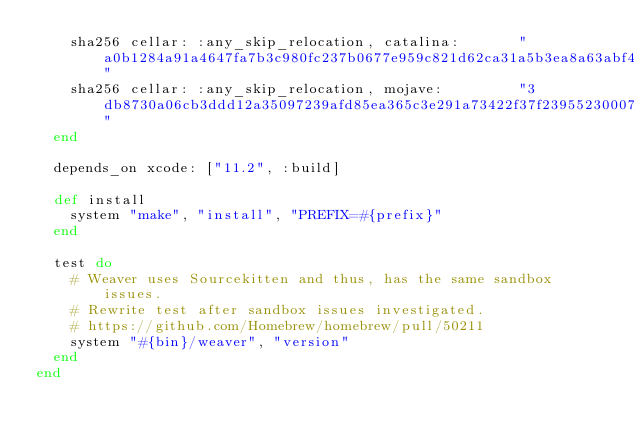<code> <loc_0><loc_0><loc_500><loc_500><_Ruby_>    sha256 cellar: :any_skip_relocation, catalina:       "a0b1284a91a4647fa7b3c980fc237b0677e959c821d62ca31a5b3ea8a63abf40"
    sha256 cellar: :any_skip_relocation, mojave:         "3db8730a06cb3ddd12a35097239afd85ea365c3e291a73422f37f23955230007"
  end

  depends_on xcode: ["11.2", :build]

  def install
    system "make", "install", "PREFIX=#{prefix}"
  end

  test do
    # Weaver uses Sourcekitten and thus, has the same sandbox issues.
    # Rewrite test after sandbox issues investigated.
    # https://github.com/Homebrew/homebrew/pull/50211
    system "#{bin}/weaver", "version"
  end
end
</code> 